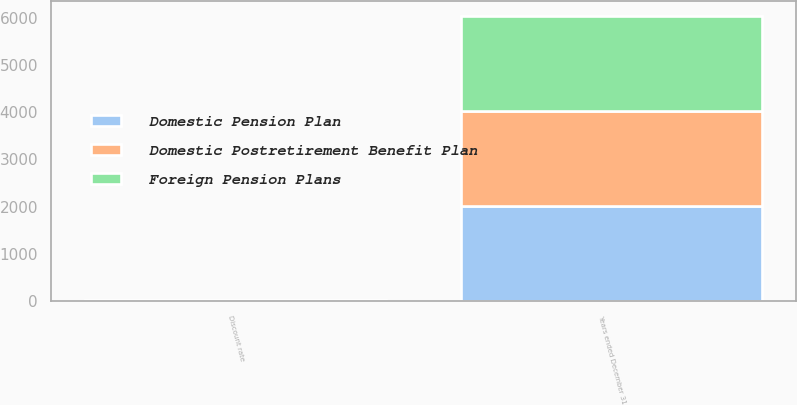Convert chart. <chart><loc_0><loc_0><loc_500><loc_500><stacked_bar_chart><ecel><fcel>Years ended December 31<fcel>Discount rate<nl><fcel>Foreign Pension Plans<fcel>2014<fcel>4.85<nl><fcel>Domestic Postretirement Benefit Plan<fcel>2014<fcel>4.29<nl><fcel>Domestic Pension Plan<fcel>2014<fcel>4.85<nl></chart> 